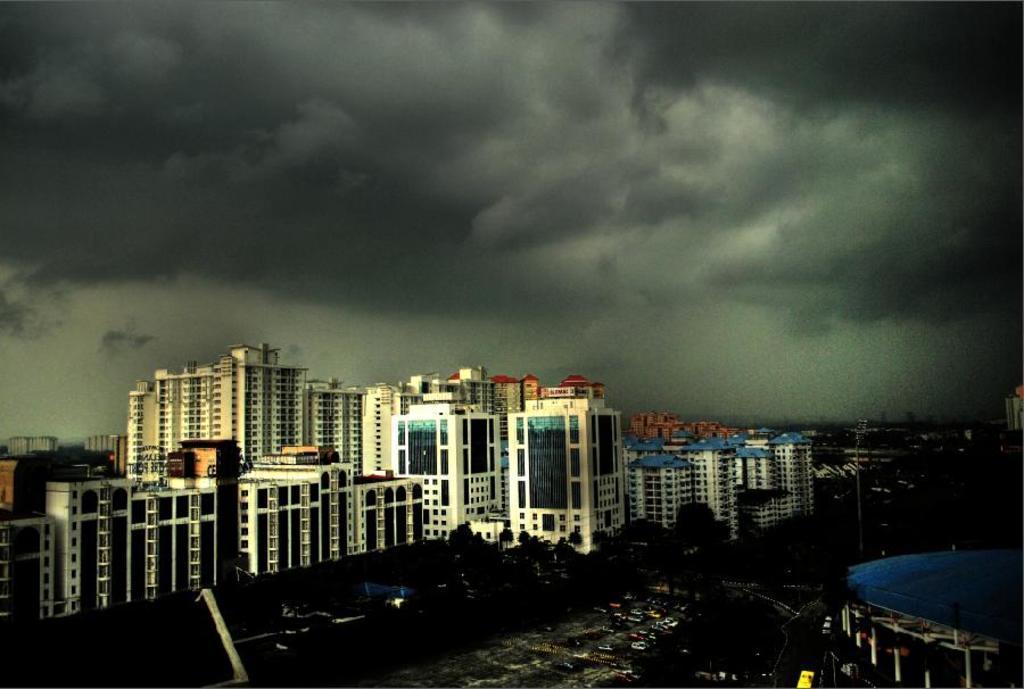Could you give a brief overview of what you see in this image? In the picture I can see buildings, trees, vehicles, poles and some other objects on the ground. In the background I can see the sky. The image is little bit dark. 